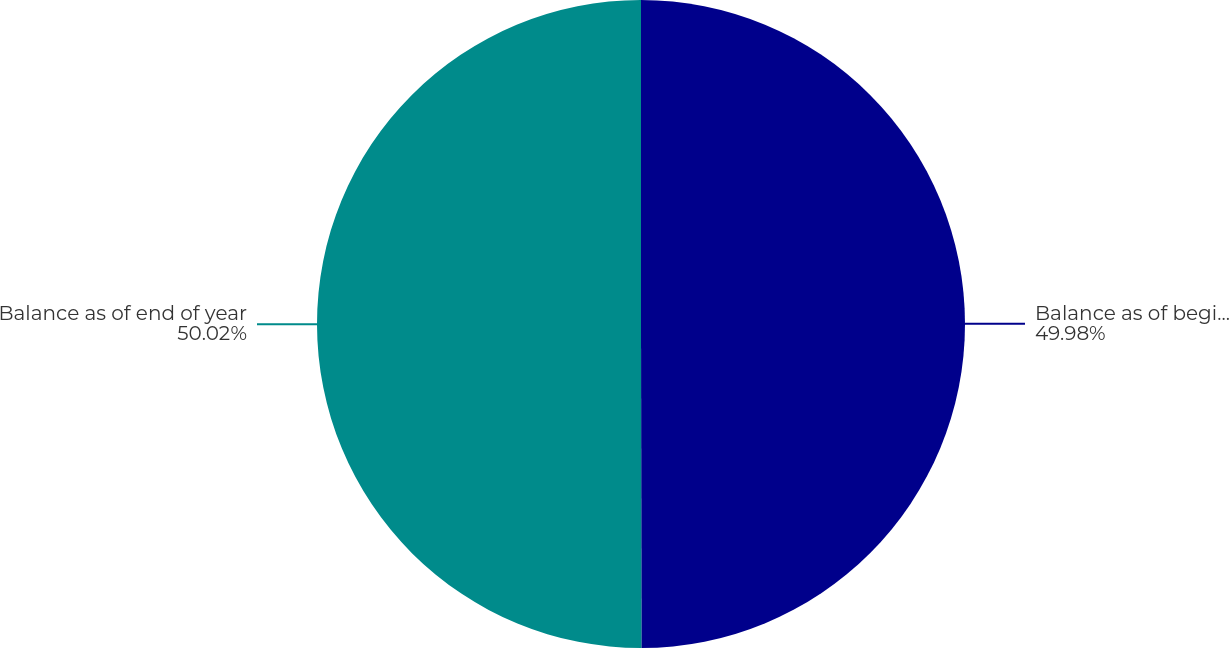Convert chart to OTSL. <chart><loc_0><loc_0><loc_500><loc_500><pie_chart><fcel>Balance as of beginning of<fcel>Balance as of end of year<nl><fcel>49.98%<fcel>50.02%<nl></chart> 